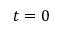<formula> <loc_0><loc_0><loc_500><loc_500>t = 0</formula> 